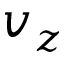Convert formula to latex. <formula><loc_0><loc_0><loc_500><loc_500>v _ { z }</formula> 